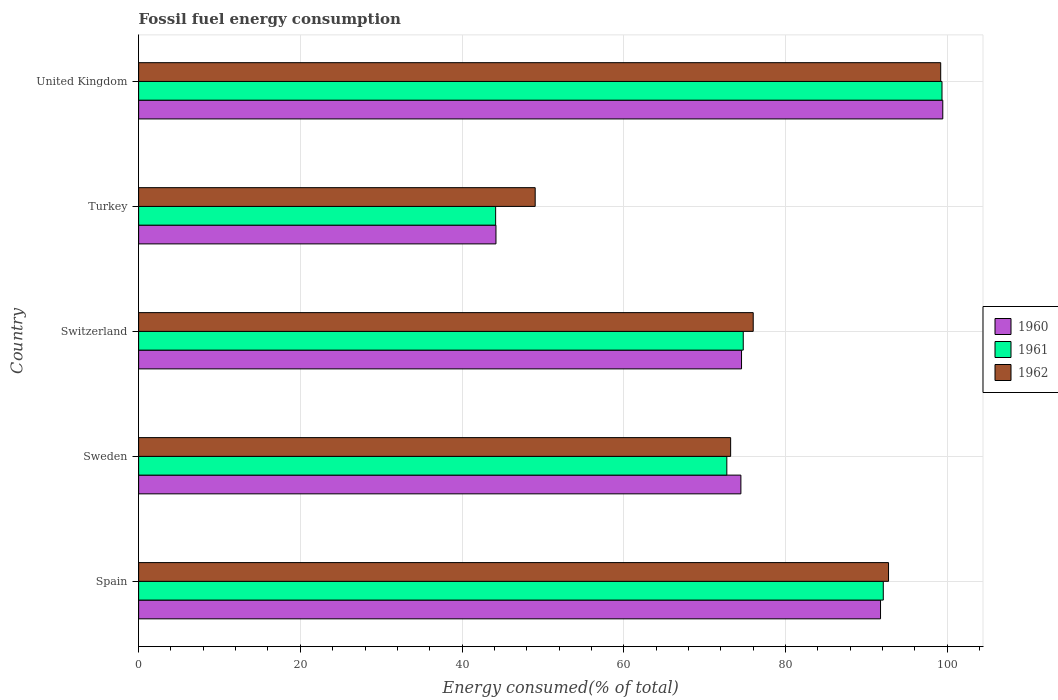How many bars are there on the 4th tick from the bottom?
Ensure brevity in your answer.  3. What is the label of the 1st group of bars from the top?
Give a very brief answer. United Kingdom. What is the percentage of energy consumed in 1962 in United Kingdom?
Offer a terse response. 99.21. Across all countries, what is the maximum percentage of energy consumed in 1962?
Keep it short and to the point. 99.21. Across all countries, what is the minimum percentage of energy consumed in 1961?
Offer a terse response. 44.16. In which country was the percentage of energy consumed in 1962 maximum?
Make the answer very short. United Kingdom. In which country was the percentage of energy consumed in 1962 minimum?
Give a very brief answer. Turkey. What is the total percentage of energy consumed in 1962 in the graph?
Give a very brief answer. 390.25. What is the difference between the percentage of energy consumed in 1961 in Sweden and that in Turkey?
Ensure brevity in your answer.  28.59. What is the difference between the percentage of energy consumed in 1962 in United Kingdom and the percentage of energy consumed in 1960 in Turkey?
Keep it short and to the point. 55.01. What is the average percentage of energy consumed in 1961 per country?
Offer a terse response. 76.63. What is the difference between the percentage of energy consumed in 1960 and percentage of energy consumed in 1962 in Spain?
Your answer should be very brief. -0.99. What is the ratio of the percentage of energy consumed in 1962 in Sweden to that in United Kingdom?
Provide a short and direct response. 0.74. What is the difference between the highest and the second highest percentage of energy consumed in 1962?
Give a very brief answer. 6.45. What is the difference between the highest and the lowest percentage of energy consumed in 1960?
Keep it short and to the point. 55.27. In how many countries, is the percentage of energy consumed in 1960 greater than the average percentage of energy consumed in 1960 taken over all countries?
Your answer should be very brief. 2. What does the 3rd bar from the top in Turkey represents?
Offer a terse response. 1960. What does the 1st bar from the bottom in United Kingdom represents?
Offer a very short reply. 1960. Is it the case that in every country, the sum of the percentage of energy consumed in 1961 and percentage of energy consumed in 1962 is greater than the percentage of energy consumed in 1960?
Ensure brevity in your answer.  Yes. Are all the bars in the graph horizontal?
Your answer should be very brief. Yes. Does the graph contain grids?
Provide a succinct answer. Yes. How many legend labels are there?
Keep it short and to the point. 3. How are the legend labels stacked?
Ensure brevity in your answer.  Vertical. What is the title of the graph?
Ensure brevity in your answer.  Fossil fuel energy consumption. What is the label or title of the X-axis?
Ensure brevity in your answer.  Energy consumed(% of total). What is the label or title of the Y-axis?
Your answer should be very brief. Country. What is the Energy consumed(% of total) in 1960 in Spain?
Make the answer very short. 91.77. What is the Energy consumed(% of total) of 1961 in Spain?
Make the answer very short. 92.1. What is the Energy consumed(% of total) of 1962 in Spain?
Ensure brevity in your answer.  92.75. What is the Energy consumed(% of total) of 1960 in Sweden?
Provide a succinct answer. 74.49. What is the Energy consumed(% of total) in 1961 in Sweden?
Offer a very short reply. 72.75. What is the Energy consumed(% of total) in 1962 in Sweden?
Provide a succinct answer. 73.23. What is the Energy consumed(% of total) of 1960 in Switzerland?
Keep it short and to the point. 74.57. What is the Energy consumed(% of total) of 1961 in Switzerland?
Your answer should be compact. 74.78. What is the Energy consumed(% of total) in 1962 in Switzerland?
Your response must be concise. 76.02. What is the Energy consumed(% of total) in 1960 in Turkey?
Ensure brevity in your answer.  44.2. What is the Energy consumed(% of total) in 1961 in Turkey?
Offer a terse response. 44.16. What is the Energy consumed(% of total) of 1962 in Turkey?
Give a very brief answer. 49.05. What is the Energy consumed(% of total) of 1960 in United Kingdom?
Provide a short and direct response. 99.46. What is the Energy consumed(% of total) in 1961 in United Kingdom?
Provide a succinct answer. 99.37. What is the Energy consumed(% of total) in 1962 in United Kingdom?
Your response must be concise. 99.21. Across all countries, what is the maximum Energy consumed(% of total) in 1960?
Your response must be concise. 99.46. Across all countries, what is the maximum Energy consumed(% of total) of 1961?
Ensure brevity in your answer.  99.37. Across all countries, what is the maximum Energy consumed(% of total) in 1962?
Offer a terse response. 99.21. Across all countries, what is the minimum Energy consumed(% of total) in 1960?
Keep it short and to the point. 44.2. Across all countries, what is the minimum Energy consumed(% of total) in 1961?
Give a very brief answer. 44.16. Across all countries, what is the minimum Energy consumed(% of total) in 1962?
Give a very brief answer. 49.05. What is the total Energy consumed(% of total) of 1960 in the graph?
Offer a very short reply. 384.49. What is the total Energy consumed(% of total) of 1961 in the graph?
Give a very brief answer. 383.17. What is the total Energy consumed(% of total) of 1962 in the graph?
Your answer should be very brief. 390.25. What is the difference between the Energy consumed(% of total) in 1960 in Spain and that in Sweden?
Keep it short and to the point. 17.27. What is the difference between the Energy consumed(% of total) of 1961 in Spain and that in Sweden?
Your response must be concise. 19.35. What is the difference between the Energy consumed(% of total) of 1962 in Spain and that in Sweden?
Give a very brief answer. 19.53. What is the difference between the Energy consumed(% of total) in 1960 in Spain and that in Switzerland?
Keep it short and to the point. 17.19. What is the difference between the Energy consumed(% of total) in 1961 in Spain and that in Switzerland?
Offer a terse response. 17.32. What is the difference between the Energy consumed(% of total) of 1962 in Spain and that in Switzerland?
Offer a very short reply. 16.74. What is the difference between the Energy consumed(% of total) of 1960 in Spain and that in Turkey?
Offer a very short reply. 47.57. What is the difference between the Energy consumed(% of total) of 1961 in Spain and that in Turkey?
Your answer should be compact. 47.95. What is the difference between the Energy consumed(% of total) in 1962 in Spain and that in Turkey?
Keep it short and to the point. 43.7. What is the difference between the Energy consumed(% of total) of 1960 in Spain and that in United Kingdom?
Provide a succinct answer. -7.7. What is the difference between the Energy consumed(% of total) in 1961 in Spain and that in United Kingdom?
Your response must be concise. -7.26. What is the difference between the Energy consumed(% of total) of 1962 in Spain and that in United Kingdom?
Offer a terse response. -6.45. What is the difference between the Energy consumed(% of total) in 1960 in Sweden and that in Switzerland?
Ensure brevity in your answer.  -0.08. What is the difference between the Energy consumed(% of total) in 1961 in Sweden and that in Switzerland?
Ensure brevity in your answer.  -2.03. What is the difference between the Energy consumed(% of total) in 1962 in Sweden and that in Switzerland?
Provide a succinct answer. -2.79. What is the difference between the Energy consumed(% of total) of 1960 in Sweden and that in Turkey?
Make the answer very short. 30.29. What is the difference between the Energy consumed(% of total) in 1961 in Sweden and that in Turkey?
Give a very brief answer. 28.59. What is the difference between the Energy consumed(% of total) in 1962 in Sweden and that in Turkey?
Provide a succinct answer. 24.18. What is the difference between the Energy consumed(% of total) in 1960 in Sweden and that in United Kingdom?
Your answer should be compact. -24.97. What is the difference between the Energy consumed(% of total) of 1961 in Sweden and that in United Kingdom?
Provide a succinct answer. -26.61. What is the difference between the Energy consumed(% of total) in 1962 in Sweden and that in United Kingdom?
Offer a very short reply. -25.98. What is the difference between the Energy consumed(% of total) in 1960 in Switzerland and that in Turkey?
Ensure brevity in your answer.  30.37. What is the difference between the Energy consumed(% of total) in 1961 in Switzerland and that in Turkey?
Your answer should be very brief. 30.62. What is the difference between the Energy consumed(% of total) in 1962 in Switzerland and that in Turkey?
Ensure brevity in your answer.  26.97. What is the difference between the Energy consumed(% of total) in 1960 in Switzerland and that in United Kingdom?
Offer a terse response. -24.89. What is the difference between the Energy consumed(% of total) in 1961 in Switzerland and that in United Kingdom?
Offer a very short reply. -24.58. What is the difference between the Energy consumed(% of total) of 1962 in Switzerland and that in United Kingdom?
Ensure brevity in your answer.  -23.19. What is the difference between the Energy consumed(% of total) of 1960 in Turkey and that in United Kingdom?
Offer a very short reply. -55.27. What is the difference between the Energy consumed(% of total) of 1961 in Turkey and that in United Kingdom?
Give a very brief answer. -55.21. What is the difference between the Energy consumed(% of total) of 1962 in Turkey and that in United Kingdom?
Your answer should be compact. -50.16. What is the difference between the Energy consumed(% of total) of 1960 in Spain and the Energy consumed(% of total) of 1961 in Sweden?
Ensure brevity in your answer.  19.01. What is the difference between the Energy consumed(% of total) in 1960 in Spain and the Energy consumed(% of total) in 1962 in Sweden?
Offer a terse response. 18.54. What is the difference between the Energy consumed(% of total) of 1961 in Spain and the Energy consumed(% of total) of 1962 in Sweden?
Give a very brief answer. 18.88. What is the difference between the Energy consumed(% of total) of 1960 in Spain and the Energy consumed(% of total) of 1961 in Switzerland?
Offer a very short reply. 16.98. What is the difference between the Energy consumed(% of total) of 1960 in Spain and the Energy consumed(% of total) of 1962 in Switzerland?
Ensure brevity in your answer.  15.75. What is the difference between the Energy consumed(% of total) in 1961 in Spain and the Energy consumed(% of total) in 1962 in Switzerland?
Your response must be concise. 16.09. What is the difference between the Energy consumed(% of total) of 1960 in Spain and the Energy consumed(% of total) of 1961 in Turkey?
Keep it short and to the point. 47.61. What is the difference between the Energy consumed(% of total) in 1960 in Spain and the Energy consumed(% of total) in 1962 in Turkey?
Your response must be concise. 42.72. What is the difference between the Energy consumed(% of total) of 1961 in Spain and the Energy consumed(% of total) of 1962 in Turkey?
Offer a terse response. 43.05. What is the difference between the Energy consumed(% of total) in 1960 in Spain and the Energy consumed(% of total) in 1961 in United Kingdom?
Offer a terse response. -7.6. What is the difference between the Energy consumed(% of total) in 1960 in Spain and the Energy consumed(% of total) in 1962 in United Kingdom?
Your response must be concise. -7.44. What is the difference between the Energy consumed(% of total) of 1961 in Spain and the Energy consumed(% of total) of 1962 in United Kingdom?
Give a very brief answer. -7.1. What is the difference between the Energy consumed(% of total) of 1960 in Sweden and the Energy consumed(% of total) of 1961 in Switzerland?
Your response must be concise. -0.29. What is the difference between the Energy consumed(% of total) of 1960 in Sweden and the Energy consumed(% of total) of 1962 in Switzerland?
Your response must be concise. -1.52. What is the difference between the Energy consumed(% of total) in 1961 in Sweden and the Energy consumed(% of total) in 1962 in Switzerland?
Provide a short and direct response. -3.26. What is the difference between the Energy consumed(% of total) in 1960 in Sweden and the Energy consumed(% of total) in 1961 in Turkey?
Your answer should be compact. 30.33. What is the difference between the Energy consumed(% of total) in 1960 in Sweden and the Energy consumed(% of total) in 1962 in Turkey?
Provide a succinct answer. 25.44. What is the difference between the Energy consumed(% of total) of 1961 in Sweden and the Energy consumed(% of total) of 1962 in Turkey?
Your response must be concise. 23.7. What is the difference between the Energy consumed(% of total) in 1960 in Sweden and the Energy consumed(% of total) in 1961 in United Kingdom?
Ensure brevity in your answer.  -24.87. What is the difference between the Energy consumed(% of total) in 1960 in Sweden and the Energy consumed(% of total) in 1962 in United Kingdom?
Provide a succinct answer. -24.71. What is the difference between the Energy consumed(% of total) of 1961 in Sweden and the Energy consumed(% of total) of 1962 in United Kingdom?
Offer a very short reply. -26.45. What is the difference between the Energy consumed(% of total) of 1960 in Switzerland and the Energy consumed(% of total) of 1961 in Turkey?
Offer a very short reply. 30.41. What is the difference between the Energy consumed(% of total) of 1960 in Switzerland and the Energy consumed(% of total) of 1962 in Turkey?
Ensure brevity in your answer.  25.52. What is the difference between the Energy consumed(% of total) in 1961 in Switzerland and the Energy consumed(% of total) in 1962 in Turkey?
Give a very brief answer. 25.73. What is the difference between the Energy consumed(% of total) of 1960 in Switzerland and the Energy consumed(% of total) of 1961 in United Kingdom?
Give a very brief answer. -24.8. What is the difference between the Energy consumed(% of total) of 1960 in Switzerland and the Energy consumed(% of total) of 1962 in United Kingdom?
Provide a succinct answer. -24.64. What is the difference between the Energy consumed(% of total) in 1961 in Switzerland and the Energy consumed(% of total) in 1962 in United Kingdom?
Provide a succinct answer. -24.42. What is the difference between the Energy consumed(% of total) in 1960 in Turkey and the Energy consumed(% of total) in 1961 in United Kingdom?
Provide a succinct answer. -55.17. What is the difference between the Energy consumed(% of total) in 1960 in Turkey and the Energy consumed(% of total) in 1962 in United Kingdom?
Ensure brevity in your answer.  -55.01. What is the difference between the Energy consumed(% of total) of 1961 in Turkey and the Energy consumed(% of total) of 1962 in United Kingdom?
Keep it short and to the point. -55.05. What is the average Energy consumed(% of total) in 1960 per country?
Provide a succinct answer. 76.9. What is the average Energy consumed(% of total) of 1961 per country?
Offer a very short reply. 76.63. What is the average Energy consumed(% of total) of 1962 per country?
Your answer should be very brief. 78.05. What is the difference between the Energy consumed(% of total) in 1960 and Energy consumed(% of total) in 1961 in Spain?
Your response must be concise. -0.34. What is the difference between the Energy consumed(% of total) of 1960 and Energy consumed(% of total) of 1962 in Spain?
Make the answer very short. -0.99. What is the difference between the Energy consumed(% of total) of 1961 and Energy consumed(% of total) of 1962 in Spain?
Ensure brevity in your answer.  -0.65. What is the difference between the Energy consumed(% of total) in 1960 and Energy consumed(% of total) in 1961 in Sweden?
Provide a short and direct response. 1.74. What is the difference between the Energy consumed(% of total) in 1960 and Energy consumed(% of total) in 1962 in Sweden?
Make the answer very short. 1.27. What is the difference between the Energy consumed(% of total) in 1961 and Energy consumed(% of total) in 1962 in Sweden?
Your answer should be compact. -0.47. What is the difference between the Energy consumed(% of total) in 1960 and Energy consumed(% of total) in 1961 in Switzerland?
Provide a short and direct response. -0.21. What is the difference between the Energy consumed(% of total) of 1960 and Energy consumed(% of total) of 1962 in Switzerland?
Make the answer very short. -1.45. What is the difference between the Energy consumed(% of total) in 1961 and Energy consumed(% of total) in 1962 in Switzerland?
Give a very brief answer. -1.23. What is the difference between the Energy consumed(% of total) of 1960 and Energy consumed(% of total) of 1962 in Turkey?
Offer a terse response. -4.85. What is the difference between the Energy consumed(% of total) of 1961 and Energy consumed(% of total) of 1962 in Turkey?
Offer a very short reply. -4.89. What is the difference between the Energy consumed(% of total) of 1960 and Energy consumed(% of total) of 1961 in United Kingdom?
Your answer should be compact. 0.1. What is the difference between the Energy consumed(% of total) in 1960 and Energy consumed(% of total) in 1962 in United Kingdom?
Your answer should be compact. 0.26. What is the difference between the Energy consumed(% of total) of 1961 and Energy consumed(% of total) of 1962 in United Kingdom?
Provide a short and direct response. 0.16. What is the ratio of the Energy consumed(% of total) in 1960 in Spain to that in Sweden?
Your answer should be very brief. 1.23. What is the ratio of the Energy consumed(% of total) in 1961 in Spain to that in Sweden?
Offer a very short reply. 1.27. What is the ratio of the Energy consumed(% of total) in 1962 in Spain to that in Sweden?
Your response must be concise. 1.27. What is the ratio of the Energy consumed(% of total) in 1960 in Spain to that in Switzerland?
Ensure brevity in your answer.  1.23. What is the ratio of the Energy consumed(% of total) of 1961 in Spain to that in Switzerland?
Offer a terse response. 1.23. What is the ratio of the Energy consumed(% of total) of 1962 in Spain to that in Switzerland?
Keep it short and to the point. 1.22. What is the ratio of the Energy consumed(% of total) in 1960 in Spain to that in Turkey?
Your response must be concise. 2.08. What is the ratio of the Energy consumed(% of total) of 1961 in Spain to that in Turkey?
Offer a terse response. 2.09. What is the ratio of the Energy consumed(% of total) of 1962 in Spain to that in Turkey?
Provide a short and direct response. 1.89. What is the ratio of the Energy consumed(% of total) in 1960 in Spain to that in United Kingdom?
Offer a terse response. 0.92. What is the ratio of the Energy consumed(% of total) of 1961 in Spain to that in United Kingdom?
Keep it short and to the point. 0.93. What is the ratio of the Energy consumed(% of total) in 1962 in Spain to that in United Kingdom?
Your answer should be compact. 0.93. What is the ratio of the Energy consumed(% of total) of 1960 in Sweden to that in Switzerland?
Your response must be concise. 1. What is the ratio of the Energy consumed(% of total) in 1961 in Sweden to that in Switzerland?
Provide a succinct answer. 0.97. What is the ratio of the Energy consumed(% of total) in 1962 in Sweden to that in Switzerland?
Keep it short and to the point. 0.96. What is the ratio of the Energy consumed(% of total) in 1960 in Sweden to that in Turkey?
Provide a succinct answer. 1.69. What is the ratio of the Energy consumed(% of total) of 1961 in Sweden to that in Turkey?
Ensure brevity in your answer.  1.65. What is the ratio of the Energy consumed(% of total) in 1962 in Sweden to that in Turkey?
Your answer should be very brief. 1.49. What is the ratio of the Energy consumed(% of total) of 1960 in Sweden to that in United Kingdom?
Keep it short and to the point. 0.75. What is the ratio of the Energy consumed(% of total) in 1961 in Sweden to that in United Kingdom?
Your response must be concise. 0.73. What is the ratio of the Energy consumed(% of total) in 1962 in Sweden to that in United Kingdom?
Give a very brief answer. 0.74. What is the ratio of the Energy consumed(% of total) in 1960 in Switzerland to that in Turkey?
Offer a very short reply. 1.69. What is the ratio of the Energy consumed(% of total) of 1961 in Switzerland to that in Turkey?
Keep it short and to the point. 1.69. What is the ratio of the Energy consumed(% of total) in 1962 in Switzerland to that in Turkey?
Your answer should be very brief. 1.55. What is the ratio of the Energy consumed(% of total) of 1960 in Switzerland to that in United Kingdom?
Give a very brief answer. 0.75. What is the ratio of the Energy consumed(% of total) of 1961 in Switzerland to that in United Kingdom?
Keep it short and to the point. 0.75. What is the ratio of the Energy consumed(% of total) of 1962 in Switzerland to that in United Kingdom?
Give a very brief answer. 0.77. What is the ratio of the Energy consumed(% of total) of 1960 in Turkey to that in United Kingdom?
Give a very brief answer. 0.44. What is the ratio of the Energy consumed(% of total) of 1961 in Turkey to that in United Kingdom?
Give a very brief answer. 0.44. What is the ratio of the Energy consumed(% of total) in 1962 in Turkey to that in United Kingdom?
Your answer should be very brief. 0.49. What is the difference between the highest and the second highest Energy consumed(% of total) in 1960?
Your answer should be very brief. 7.7. What is the difference between the highest and the second highest Energy consumed(% of total) of 1961?
Your answer should be very brief. 7.26. What is the difference between the highest and the second highest Energy consumed(% of total) of 1962?
Give a very brief answer. 6.45. What is the difference between the highest and the lowest Energy consumed(% of total) of 1960?
Your answer should be compact. 55.27. What is the difference between the highest and the lowest Energy consumed(% of total) in 1961?
Ensure brevity in your answer.  55.21. What is the difference between the highest and the lowest Energy consumed(% of total) of 1962?
Your response must be concise. 50.16. 